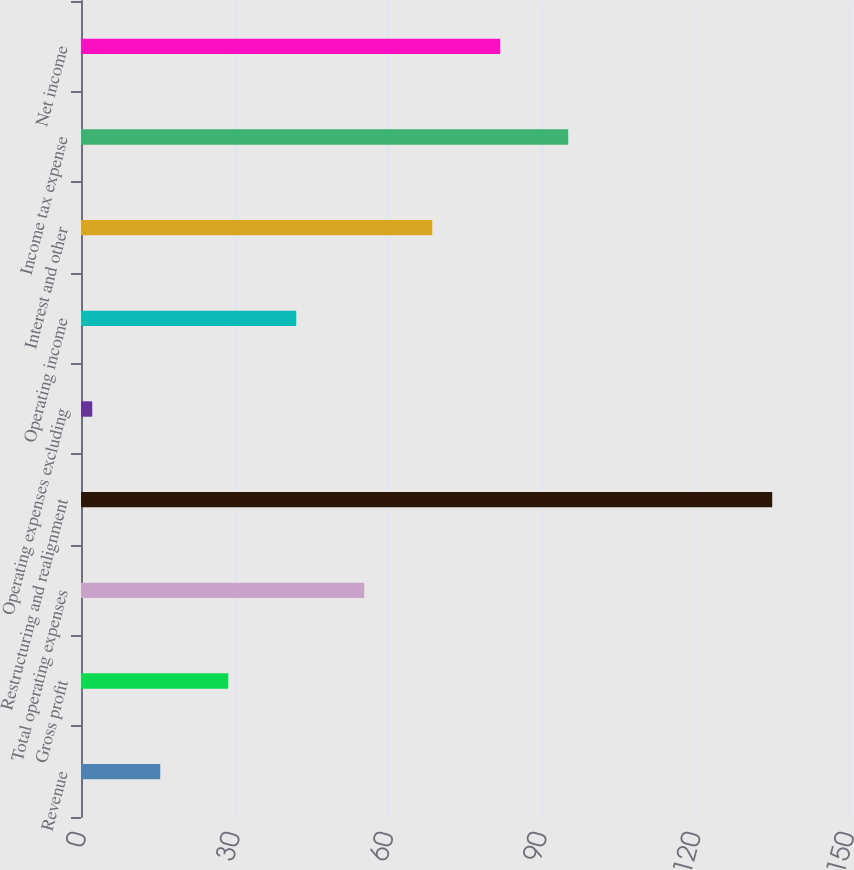<chart> <loc_0><loc_0><loc_500><loc_500><bar_chart><fcel>Revenue<fcel>Gross profit<fcel>Total operating expenses<fcel>Restructuring and realignment<fcel>Operating expenses excluding<fcel>Operating income<fcel>Interest and other<fcel>Income tax expense<fcel>Net income<nl><fcel>15.48<fcel>28.76<fcel>55.32<fcel>135<fcel>2.2<fcel>42.04<fcel>68.6<fcel>95.16<fcel>81.88<nl></chart> 